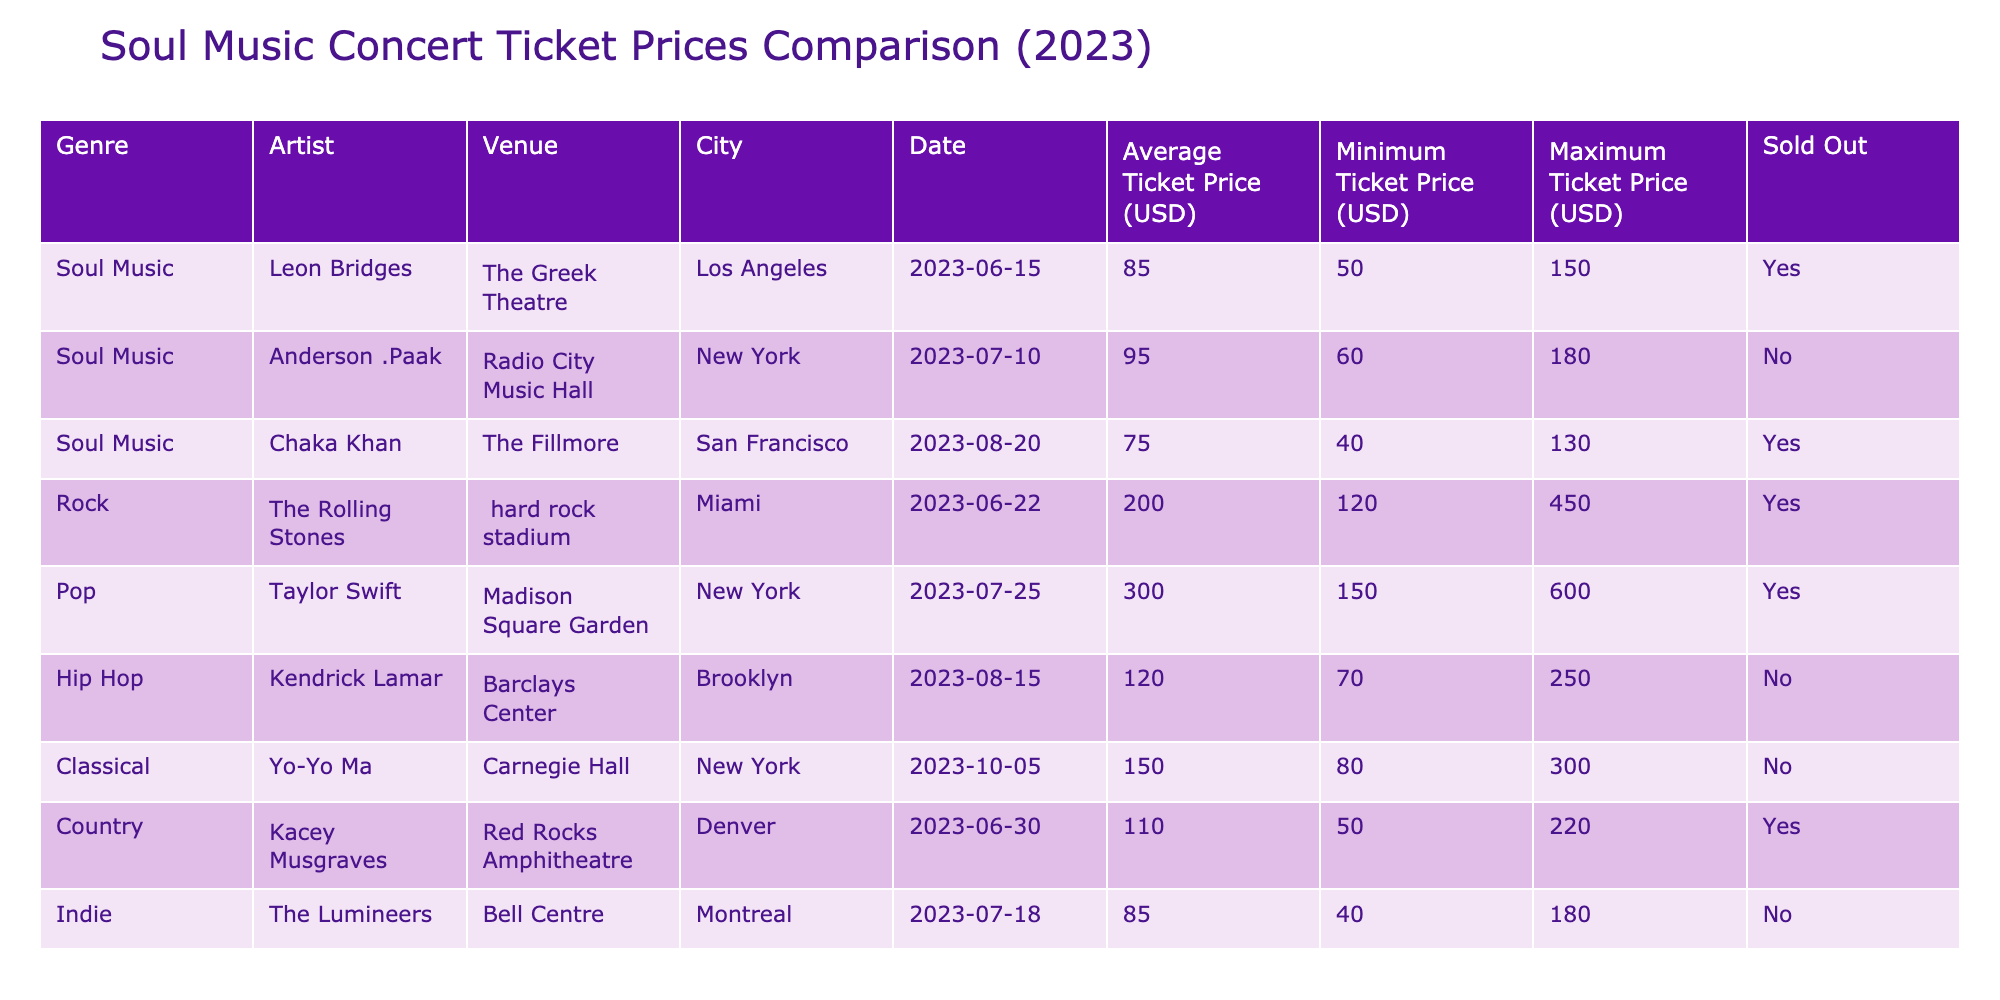What is the average ticket price for soul music concerts in 2023? To find the average ticket price for soul music concerts, sum the average ticket prices of the soul music concerts: 85 + 95 + 75 = 255. There are 3 concerts, so the average is 255 / 3 = 85.
Answer: 85 Which soul music concert has the highest maximum ticket price? By looking at the table, the maximum ticket prices for the soul music concerts are 150 for Leon Bridges, 180 for Anderson .Paak, and 130 for Chaka Khan. The highest maximum ticket price is 180 for Anderson .Paak.
Answer: 180 Is the concert by Leon Bridges sold out? The table indicates that Leon Bridges' concert is marked as 'Yes' for sold out. This means that the concert has sold all its available tickets.
Answer: Yes How much more expensive is the average ticket price for pop concerts compared to soul music concerts? The average ticket price for pop concerts is 300. The average ticket price for soul music concerts is 85. To find the difference, subtract 85 from 300, which equals 215.
Answer: 215 Is the ticket price for Chaka Khan's concert less than 80 dollars? The average ticket price for Chaka Khan's concert is 75 dollars, which is less than 80. Therefore, the statement is true.
Answer: Yes What is the total average ticket price for all genres combined? The average ticket prices for each genre are: Soul (85), Rock (200), Pop (300), Hip Hop (120), Classical (150), Country (110), and Indie (85). The total sum of these is 85 + 200 + 300 + 120 + 150 + 110 + 85 = 1050. There are 7 genres, so the total average is 1050 / 7 = approximately 150.
Answer: 150 Which city had the cheapest minimum ticket price for a concert? The minimum ticket prices in the table are 50 (Leon Bridges), 60 (Anderson .Paak), 40 (Chaka Khan), 120 (Rolling Stones), 150 (Taylor Swift), 70 (Kendrick Lamar), 50 (Kacey Musgraves), and 40 (The Lumineers). The cheapest is 40 dollars, which belongs to both Chaka Khan and The Lumineers, who performed in San Francisco and Montreal, respectively.
Answer: 40 How many concerts in total were sold out, regardless of genre? By examining the Sold Out column, we see that the sold-out concerts are Leon Bridges, Chaka Khan, The Rolling Stones, Taylor Swift, and Kacey Musgraves. That gives us a total of 5 sold-out concerts.
Answer: 5 What is the difference between the maximum ticket price of rock concerts and soul music concerts? The maximum ticket price for rock concerts (The Rolling Stones) is 450, while for soul music (Anderson .Paak), it is 180. The difference is calculated as 450 - 180 = 270.
Answer: 270 